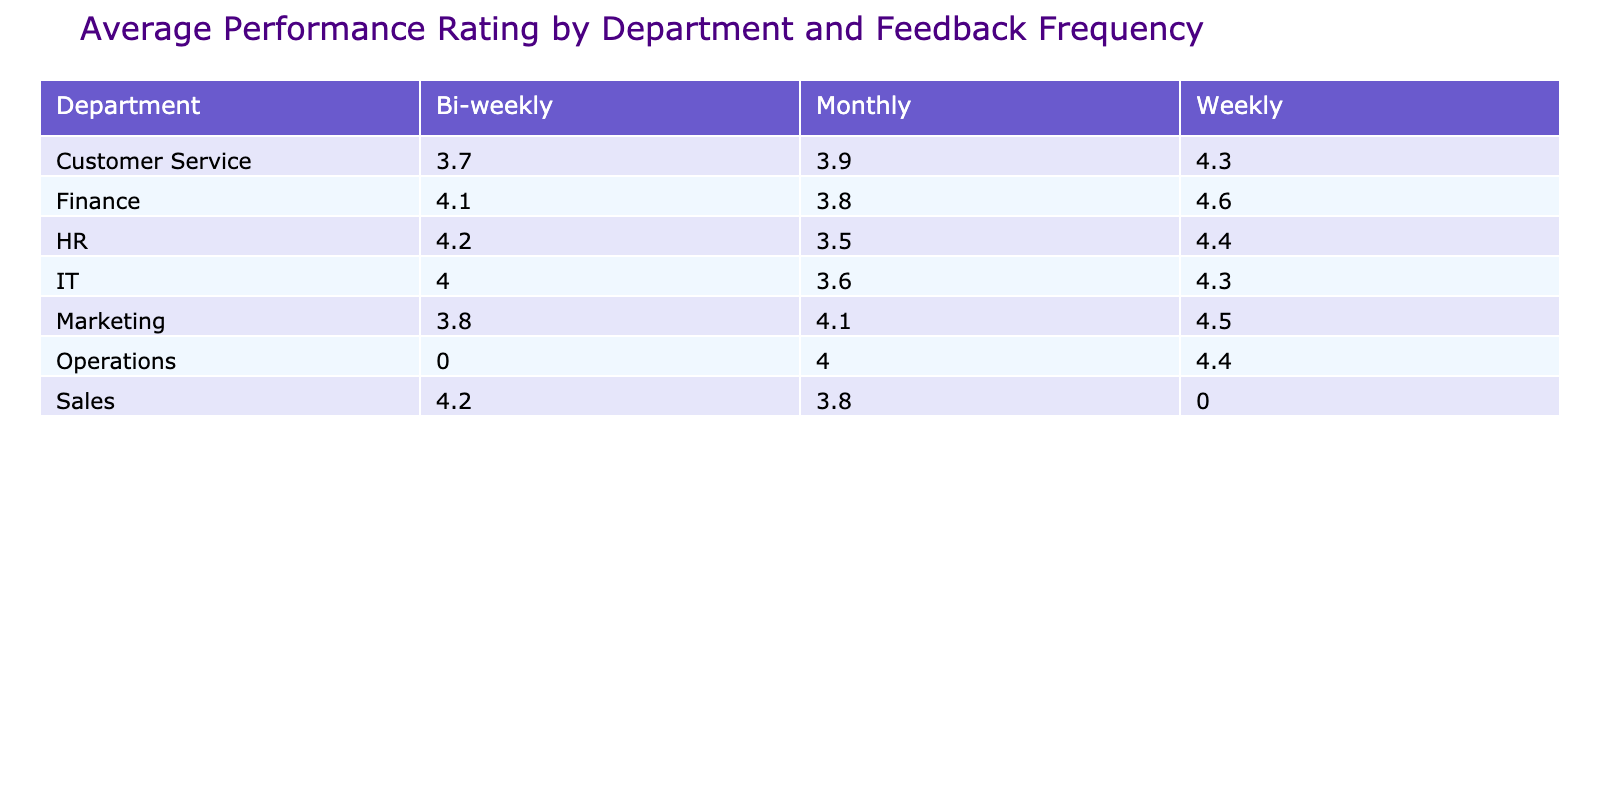What is the average performance rating for the IT department? The IT department has three employees with performance ratings of 4.3, 3.6, and 4.0. To find the average, sum these ratings: 4.3 + 3.6 + 4.0 = 11.9, and then divide by the number of employees, which is 3. Therefore, the average is 11.9 / 3 = 3.97.
Answer: 3.97 Which department has the highest average performance rating? By comparing the average ratings across all departments, the Marketing department averages 4.2 (from ratings 4.5, 3.8, and 4.1). The other departments have lower averages, making Marketing the highest.
Answer: Marketing Is the feedback frequency for the HR department primarily bi-weekly? The HR department has two employees with bi-weekly feedback frequency, which is less than half, as it also has three employees with monthly feedback. Therefore, it is false to say the frequency is primarily bi-weekly.
Answer: No What is the difference in average performance rating between the Finance and Sales departments? The average performance rating for Finance is calculated as (4.6 + 3.8 + 4.1) / 3 = 4.17, and for Sales, it's (3.7 + 4.2 + 3.9) / 3 = 3.93. The difference between the two averages is 4.17 - 3.93 = 0.24.
Answer: 0.24 Is there any employee in the Customer Service department with a performance rating greater than 4.0? Checking the ratings, Andrew Kim has a performance rating of 4.3, which is greater than 4.0. Thus, the answer is yes.
Answer: Yes What is the average feedback frequency rating for the Operations department? The Operations department has two employees with feedback frequency ratings (Monthly and Weekly). To find the average, first convert the frequencies into numerical values (Monthly = 1, Bi-weekly = 2, Weekly = 3). The average is then calculated; however, since the frequencies are more categorical, this question does not apply here as a summarization based solely on numerical average does not make sense without a scale.
Answer: Not applicable Which department has the most employees receiving weekly feedback? By checking the table, both Marketing and Customer Service departments have 2 employees receiving weekly feedback each, while other departments have either none or fewer. Thus, no single department stands out as having the most.
Answer: Tie between Marketing and Customer Service How many years of experience does the employee with the highest performance rating have? The highest performance rating in the table is 4.6, which belongs to Kevin Chen in the Finance department. He has 8 years of experience, making him the most experienced in this context.
Answer: 8 years 